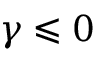<formula> <loc_0><loc_0><loc_500><loc_500>\gamma \leqslant 0</formula> 